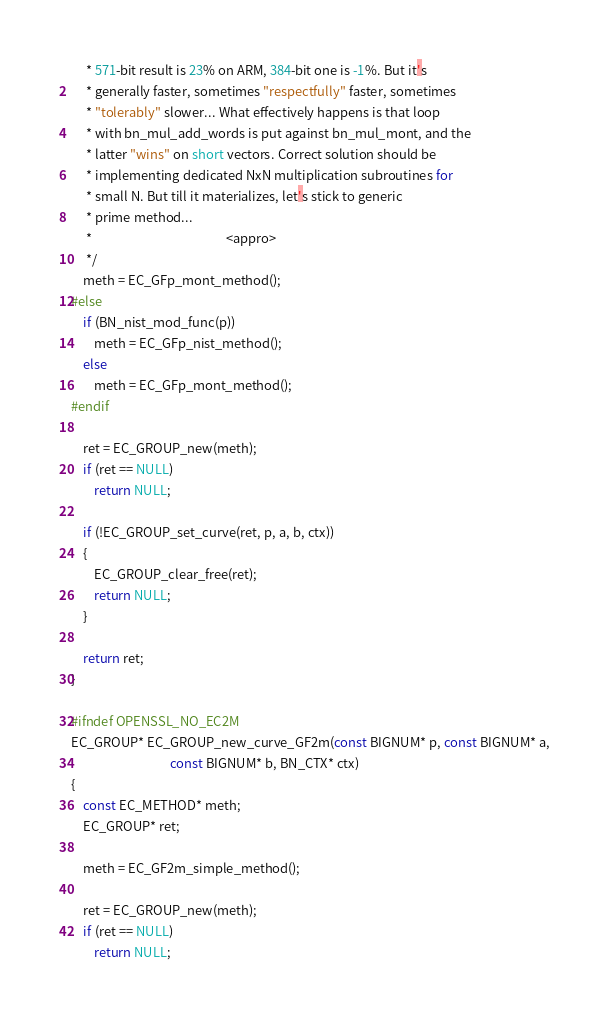Convert code to text. <code><loc_0><loc_0><loc_500><loc_500><_C_>     * 571-bit result is 23% on ARM, 384-bit one is -1%. But it's
     * generally faster, sometimes "respectfully" faster, sometimes
     * "tolerably" slower... What effectively happens is that loop
     * with bn_mul_add_words is put against bn_mul_mont, and the
     * latter "wins" on short vectors. Correct solution should be
     * implementing dedicated NxN multiplication subroutines for
     * small N. But till it materializes, let's stick to generic
     * prime method...
     *                                              <appro>
     */
    meth = EC_GFp_mont_method();
#else
    if (BN_nist_mod_func(p))
        meth = EC_GFp_nist_method();
    else
        meth = EC_GFp_mont_method();
#endif

    ret = EC_GROUP_new(meth);
    if (ret == NULL)
        return NULL;

    if (!EC_GROUP_set_curve(ret, p, a, b, ctx))
    {
        EC_GROUP_clear_free(ret);
        return NULL;
    }

    return ret;
}

#ifndef OPENSSL_NO_EC2M
EC_GROUP* EC_GROUP_new_curve_GF2m(const BIGNUM* p, const BIGNUM* a,
                                  const BIGNUM* b, BN_CTX* ctx)
{
    const EC_METHOD* meth;
    EC_GROUP* ret;

    meth = EC_GF2m_simple_method();

    ret = EC_GROUP_new(meth);
    if (ret == NULL)
        return NULL;
</code> 